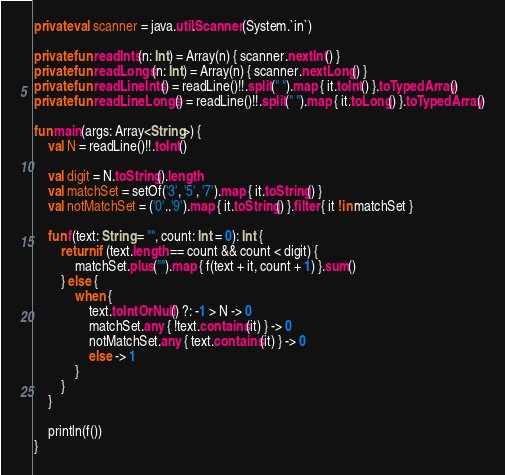Convert code to text. <code><loc_0><loc_0><loc_500><loc_500><_Kotlin_>private val scanner = java.util.Scanner(System.`in`)

private fun readInts(n: Int) = Array(n) { scanner.nextInt() }
private fun readLongs(n: Int) = Array(n) { scanner.nextLong() }
private fun readLineInts() = readLine()!!.split(" ").map { it.toInt() }.toTypedArray()
private fun readLineLongs() = readLine()!!.split(" ").map { it.toLong() }.toTypedArray()

fun main(args: Array<String>) {
    val N = readLine()!!.toInt()

    val digit = N.toString().length
    val matchSet = setOf('3', '5', '7').map { it.toString() }
    val notMatchSet = ('0'..'9').map { it.toString() }.filter { it !in matchSet }

    fun f(text: String = "", count: Int = 0): Int {
        return if (text.length == count && count < digit) {
            matchSet.plus("").map { f(text + it, count + 1) }.sum()
        } else {
            when {
                text.toIntOrNull() ?: -1 > N -> 0
                matchSet.any { !text.contains(it) } -> 0
                notMatchSet.any { text.contains(it) } -> 0
                else -> 1
            }
        }
    }

    println(f())
}</code> 